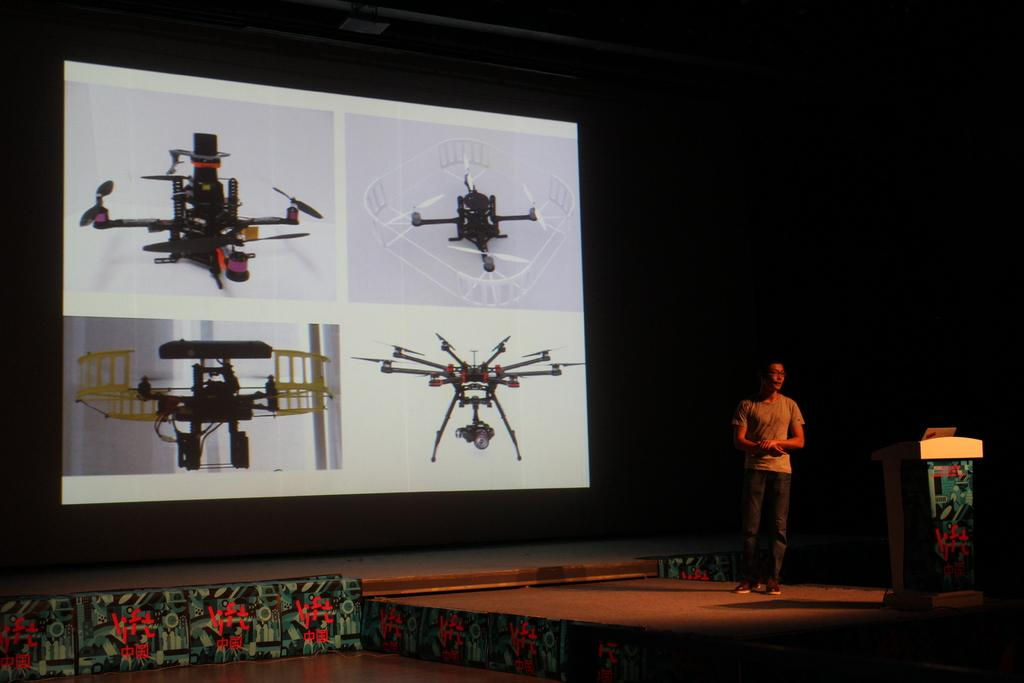What is the person in the image doing? The person is standing on a stage. What object is on the podium in front of the person? There is a mic on the podium. What can be seen behind the person on the stage? There is a screen visible. What type of content is displayed on the screen? Pictures of machines are displayed on the screen. Can you see a letter being handed to a donkey in the image? No, there is no letter or donkey present in the image. 